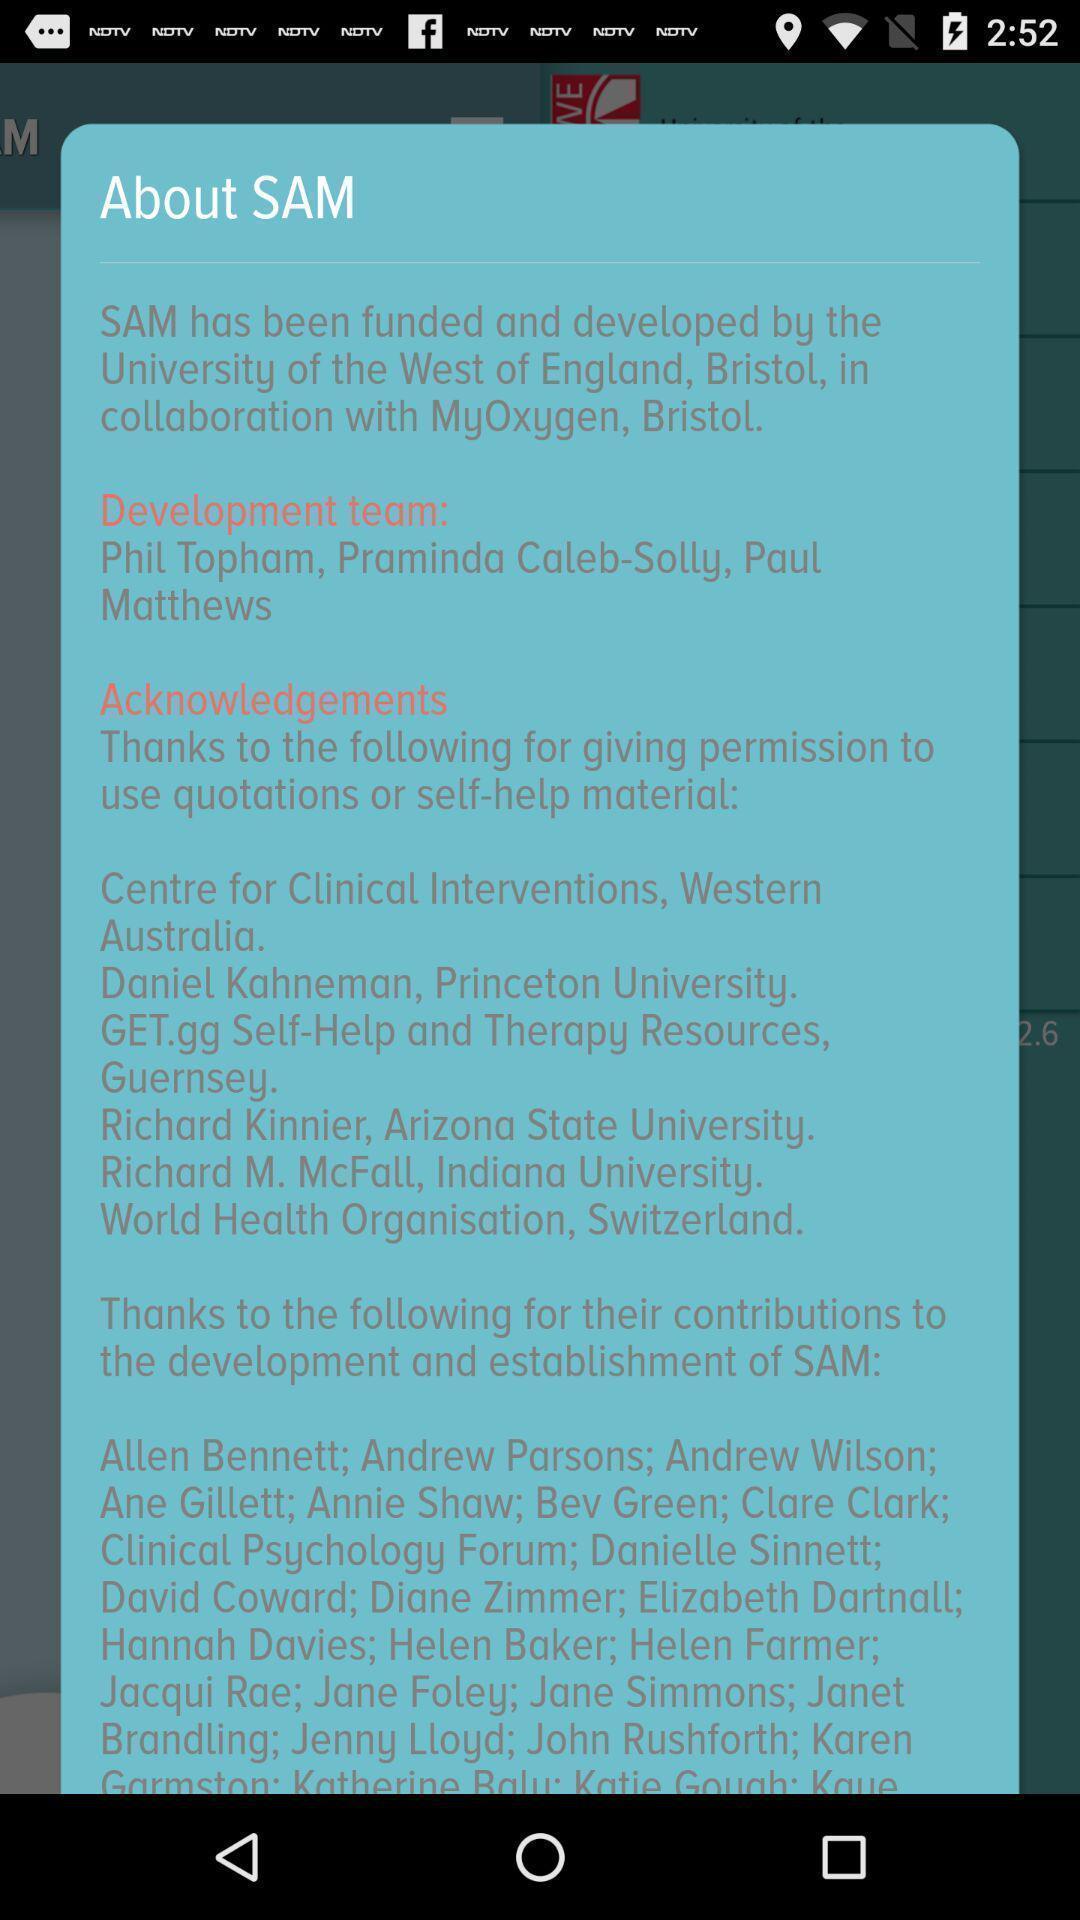Explain what's happening in this screen capture. Pop-up shows information about sam. 